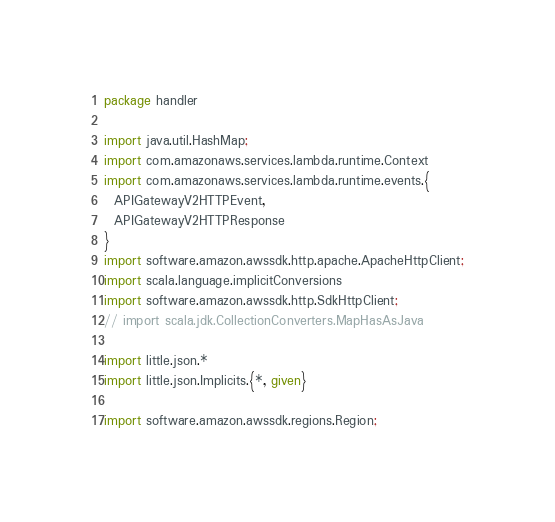Convert code to text. <code><loc_0><loc_0><loc_500><loc_500><_Scala_>package handler

import java.util.HashMap;
import com.amazonaws.services.lambda.runtime.Context
import com.amazonaws.services.lambda.runtime.events.{
  APIGatewayV2HTTPEvent,
  APIGatewayV2HTTPResponse
}
import software.amazon.awssdk.http.apache.ApacheHttpClient;
import scala.language.implicitConversions
import software.amazon.awssdk.http.SdkHttpClient;
// import scala.jdk.CollectionConverters.MapHasAsJava

import little.json.*
import little.json.Implicits.{*, given}

import software.amazon.awssdk.regions.Region;</code> 